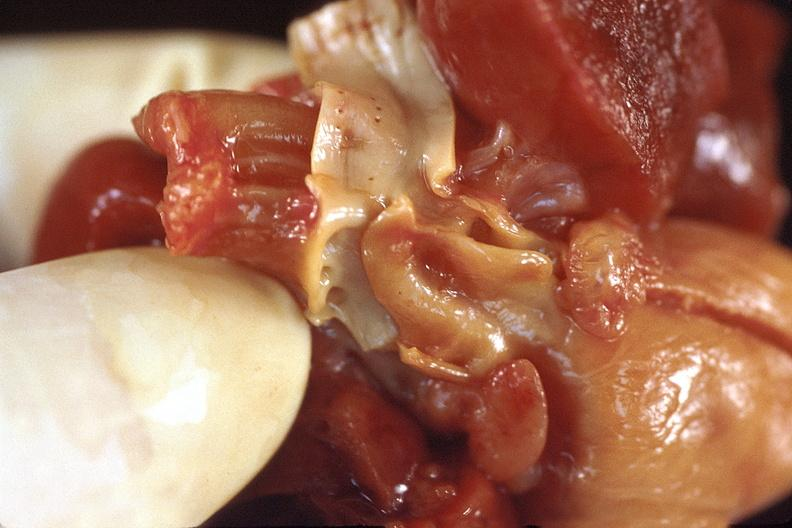does this image show heart, patent ductus arteriosis in a pateint with hyaline membrane disease?
Answer the question using a single word or phrase. Yes 